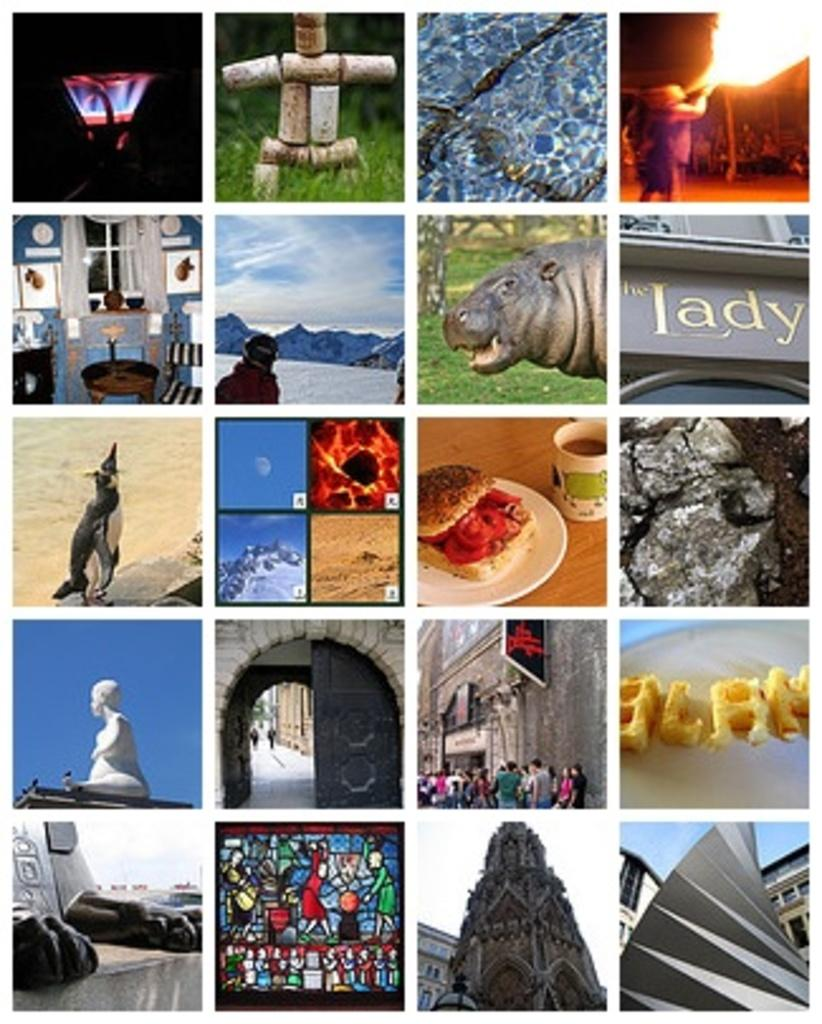What type of living organisms can be seen in the image? The image contains animals. What type of natural environment is visible in the image? There is grass visible in the image. What is the source of heat or light in the image? There is fire in the image. Who or what else is present in the image? There are people and buildings visible in the image. What is visible in the sky in the image? The sky is visible in the image. Are there any artistic elements in the image? Yes, there are sculptures in the image. What other objects can be seen in the image? There are other objects in the image. What type of decision can be seen being made by the planes in the image? There are no planes present in the image, so no decisions can be observed. What type of pancake is being served to the animals in the image? There are no pancakes or animals present in the image, so no such interaction can be observed. 